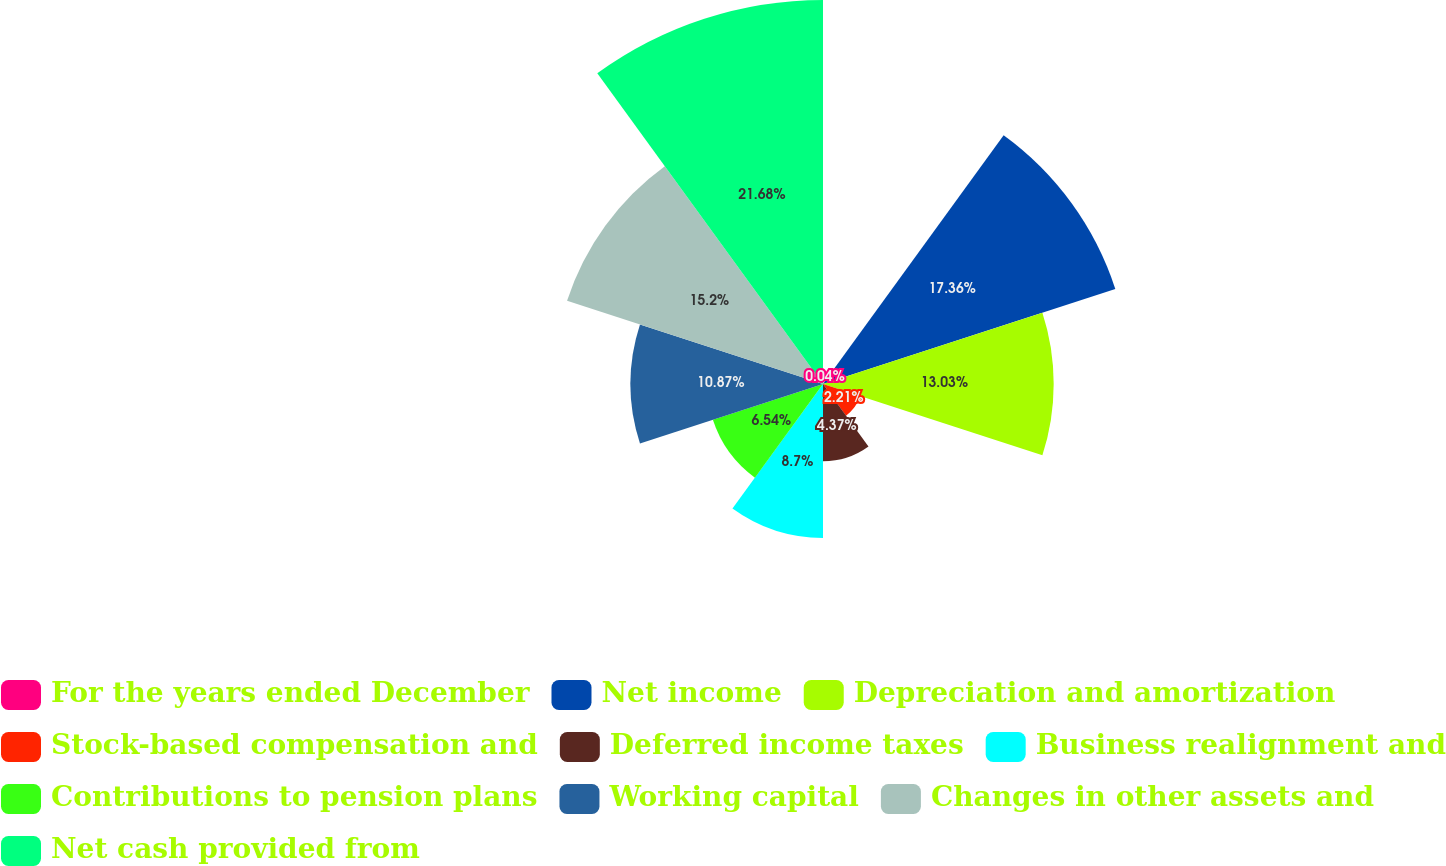Convert chart to OTSL. <chart><loc_0><loc_0><loc_500><loc_500><pie_chart><fcel>For the years ended December<fcel>Net income<fcel>Depreciation and amortization<fcel>Stock-based compensation and<fcel>Deferred income taxes<fcel>Business realignment and<fcel>Contributions to pension plans<fcel>Working capital<fcel>Changes in other assets and<fcel>Net cash provided from<nl><fcel>0.04%<fcel>17.36%<fcel>13.03%<fcel>2.21%<fcel>4.37%<fcel>8.7%<fcel>6.54%<fcel>10.87%<fcel>15.2%<fcel>21.69%<nl></chart> 